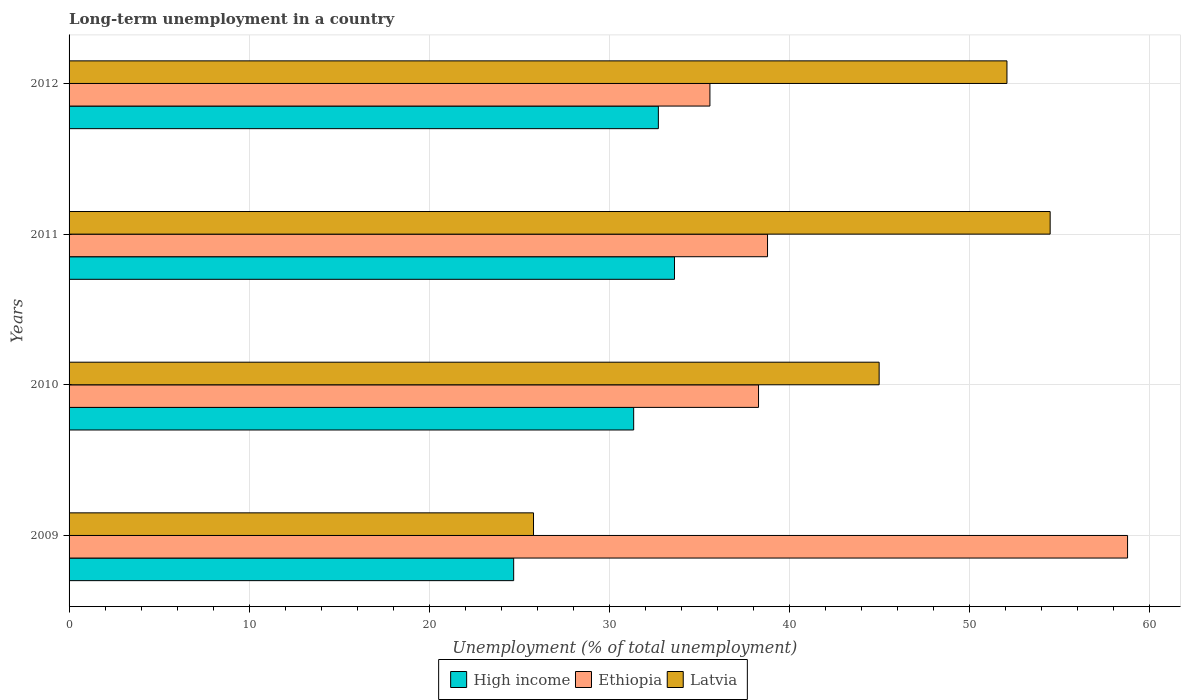Are the number of bars per tick equal to the number of legend labels?
Offer a very short reply. Yes. Are the number of bars on each tick of the Y-axis equal?
Offer a very short reply. Yes. How many bars are there on the 2nd tick from the top?
Provide a succinct answer. 3. How many bars are there on the 1st tick from the bottom?
Provide a short and direct response. 3. In how many cases, is the number of bars for a given year not equal to the number of legend labels?
Make the answer very short. 0. What is the percentage of long-term unemployed population in Ethiopia in 2009?
Your answer should be compact. 58.8. Across all years, what is the maximum percentage of long-term unemployed population in Latvia?
Your response must be concise. 54.5. Across all years, what is the minimum percentage of long-term unemployed population in Latvia?
Provide a short and direct response. 25.8. In which year was the percentage of long-term unemployed population in Latvia minimum?
Offer a very short reply. 2009. What is the total percentage of long-term unemployed population in Latvia in the graph?
Make the answer very short. 177.4. What is the difference between the percentage of long-term unemployed population in Ethiopia in 2010 and that in 2012?
Your answer should be very brief. 2.7. What is the difference between the percentage of long-term unemployed population in Latvia in 2011 and the percentage of long-term unemployed population in Ethiopia in 2012?
Keep it short and to the point. 18.9. What is the average percentage of long-term unemployed population in High income per year?
Provide a short and direct response. 30.61. In the year 2010, what is the difference between the percentage of long-term unemployed population in High income and percentage of long-term unemployed population in Ethiopia?
Make the answer very short. -6.94. What is the ratio of the percentage of long-term unemployed population in Ethiopia in 2009 to that in 2011?
Keep it short and to the point. 1.52. Is the difference between the percentage of long-term unemployed population in High income in 2009 and 2011 greater than the difference between the percentage of long-term unemployed population in Ethiopia in 2009 and 2011?
Ensure brevity in your answer.  No. What is the difference between the highest and the second highest percentage of long-term unemployed population in High income?
Offer a very short reply. 0.9. What is the difference between the highest and the lowest percentage of long-term unemployed population in Ethiopia?
Keep it short and to the point. 23.2. In how many years, is the percentage of long-term unemployed population in Latvia greater than the average percentage of long-term unemployed population in Latvia taken over all years?
Your answer should be compact. 3. What does the 2nd bar from the top in 2012 represents?
Provide a succinct answer. Ethiopia. What does the 1st bar from the bottom in 2012 represents?
Offer a terse response. High income. How many bars are there?
Provide a succinct answer. 12. How many years are there in the graph?
Provide a short and direct response. 4. What is the difference between two consecutive major ticks on the X-axis?
Make the answer very short. 10. Does the graph contain any zero values?
Keep it short and to the point. No. Does the graph contain grids?
Your response must be concise. Yes. How are the legend labels stacked?
Offer a terse response. Horizontal. What is the title of the graph?
Give a very brief answer. Long-term unemployment in a country. Does "Greenland" appear as one of the legend labels in the graph?
Ensure brevity in your answer.  No. What is the label or title of the X-axis?
Make the answer very short. Unemployment (% of total unemployment). What is the label or title of the Y-axis?
Ensure brevity in your answer.  Years. What is the Unemployment (% of total unemployment) in High income in 2009?
Make the answer very short. 24.7. What is the Unemployment (% of total unemployment) of Ethiopia in 2009?
Keep it short and to the point. 58.8. What is the Unemployment (% of total unemployment) in Latvia in 2009?
Your response must be concise. 25.8. What is the Unemployment (% of total unemployment) in High income in 2010?
Keep it short and to the point. 31.36. What is the Unemployment (% of total unemployment) in Ethiopia in 2010?
Your response must be concise. 38.3. What is the Unemployment (% of total unemployment) of Latvia in 2010?
Offer a very short reply. 45. What is the Unemployment (% of total unemployment) of High income in 2011?
Provide a succinct answer. 33.63. What is the Unemployment (% of total unemployment) in Ethiopia in 2011?
Give a very brief answer. 38.8. What is the Unemployment (% of total unemployment) of Latvia in 2011?
Ensure brevity in your answer.  54.5. What is the Unemployment (% of total unemployment) of High income in 2012?
Keep it short and to the point. 32.74. What is the Unemployment (% of total unemployment) in Ethiopia in 2012?
Your response must be concise. 35.6. What is the Unemployment (% of total unemployment) in Latvia in 2012?
Your answer should be very brief. 52.1. Across all years, what is the maximum Unemployment (% of total unemployment) in High income?
Make the answer very short. 33.63. Across all years, what is the maximum Unemployment (% of total unemployment) in Ethiopia?
Provide a succinct answer. 58.8. Across all years, what is the maximum Unemployment (% of total unemployment) of Latvia?
Make the answer very short. 54.5. Across all years, what is the minimum Unemployment (% of total unemployment) in High income?
Provide a succinct answer. 24.7. Across all years, what is the minimum Unemployment (% of total unemployment) of Ethiopia?
Ensure brevity in your answer.  35.6. Across all years, what is the minimum Unemployment (% of total unemployment) of Latvia?
Your answer should be compact. 25.8. What is the total Unemployment (% of total unemployment) of High income in the graph?
Keep it short and to the point. 122.43. What is the total Unemployment (% of total unemployment) of Ethiopia in the graph?
Ensure brevity in your answer.  171.5. What is the total Unemployment (% of total unemployment) in Latvia in the graph?
Offer a terse response. 177.4. What is the difference between the Unemployment (% of total unemployment) of High income in 2009 and that in 2010?
Ensure brevity in your answer.  -6.67. What is the difference between the Unemployment (% of total unemployment) of Latvia in 2009 and that in 2010?
Your response must be concise. -19.2. What is the difference between the Unemployment (% of total unemployment) of High income in 2009 and that in 2011?
Your answer should be very brief. -8.93. What is the difference between the Unemployment (% of total unemployment) of Ethiopia in 2009 and that in 2011?
Keep it short and to the point. 20. What is the difference between the Unemployment (% of total unemployment) of Latvia in 2009 and that in 2011?
Provide a short and direct response. -28.7. What is the difference between the Unemployment (% of total unemployment) of High income in 2009 and that in 2012?
Your response must be concise. -8.04. What is the difference between the Unemployment (% of total unemployment) in Ethiopia in 2009 and that in 2012?
Offer a terse response. 23.2. What is the difference between the Unemployment (% of total unemployment) of Latvia in 2009 and that in 2012?
Your answer should be very brief. -26.3. What is the difference between the Unemployment (% of total unemployment) in High income in 2010 and that in 2011?
Your answer should be very brief. -2.27. What is the difference between the Unemployment (% of total unemployment) of Ethiopia in 2010 and that in 2011?
Give a very brief answer. -0.5. What is the difference between the Unemployment (% of total unemployment) in Latvia in 2010 and that in 2011?
Your answer should be very brief. -9.5. What is the difference between the Unemployment (% of total unemployment) of High income in 2010 and that in 2012?
Your response must be concise. -1.37. What is the difference between the Unemployment (% of total unemployment) in Latvia in 2010 and that in 2012?
Keep it short and to the point. -7.1. What is the difference between the Unemployment (% of total unemployment) of High income in 2011 and that in 2012?
Provide a succinct answer. 0.9. What is the difference between the Unemployment (% of total unemployment) of Latvia in 2011 and that in 2012?
Keep it short and to the point. 2.4. What is the difference between the Unemployment (% of total unemployment) of High income in 2009 and the Unemployment (% of total unemployment) of Ethiopia in 2010?
Make the answer very short. -13.6. What is the difference between the Unemployment (% of total unemployment) of High income in 2009 and the Unemployment (% of total unemployment) of Latvia in 2010?
Your answer should be very brief. -20.3. What is the difference between the Unemployment (% of total unemployment) in High income in 2009 and the Unemployment (% of total unemployment) in Ethiopia in 2011?
Give a very brief answer. -14.1. What is the difference between the Unemployment (% of total unemployment) in High income in 2009 and the Unemployment (% of total unemployment) in Latvia in 2011?
Keep it short and to the point. -29.8. What is the difference between the Unemployment (% of total unemployment) in High income in 2009 and the Unemployment (% of total unemployment) in Ethiopia in 2012?
Your response must be concise. -10.9. What is the difference between the Unemployment (% of total unemployment) in High income in 2009 and the Unemployment (% of total unemployment) in Latvia in 2012?
Offer a very short reply. -27.4. What is the difference between the Unemployment (% of total unemployment) of Ethiopia in 2009 and the Unemployment (% of total unemployment) of Latvia in 2012?
Offer a very short reply. 6.7. What is the difference between the Unemployment (% of total unemployment) of High income in 2010 and the Unemployment (% of total unemployment) of Ethiopia in 2011?
Ensure brevity in your answer.  -7.44. What is the difference between the Unemployment (% of total unemployment) of High income in 2010 and the Unemployment (% of total unemployment) of Latvia in 2011?
Ensure brevity in your answer.  -23.14. What is the difference between the Unemployment (% of total unemployment) in Ethiopia in 2010 and the Unemployment (% of total unemployment) in Latvia in 2011?
Your answer should be compact. -16.2. What is the difference between the Unemployment (% of total unemployment) of High income in 2010 and the Unemployment (% of total unemployment) of Ethiopia in 2012?
Give a very brief answer. -4.24. What is the difference between the Unemployment (% of total unemployment) in High income in 2010 and the Unemployment (% of total unemployment) in Latvia in 2012?
Provide a succinct answer. -20.74. What is the difference between the Unemployment (% of total unemployment) in High income in 2011 and the Unemployment (% of total unemployment) in Ethiopia in 2012?
Provide a short and direct response. -1.97. What is the difference between the Unemployment (% of total unemployment) in High income in 2011 and the Unemployment (% of total unemployment) in Latvia in 2012?
Make the answer very short. -18.47. What is the average Unemployment (% of total unemployment) in High income per year?
Your answer should be very brief. 30.61. What is the average Unemployment (% of total unemployment) in Ethiopia per year?
Provide a succinct answer. 42.88. What is the average Unemployment (% of total unemployment) of Latvia per year?
Your answer should be compact. 44.35. In the year 2009, what is the difference between the Unemployment (% of total unemployment) of High income and Unemployment (% of total unemployment) of Ethiopia?
Keep it short and to the point. -34.1. In the year 2009, what is the difference between the Unemployment (% of total unemployment) in High income and Unemployment (% of total unemployment) in Latvia?
Offer a very short reply. -1.1. In the year 2009, what is the difference between the Unemployment (% of total unemployment) in Ethiopia and Unemployment (% of total unemployment) in Latvia?
Keep it short and to the point. 33. In the year 2010, what is the difference between the Unemployment (% of total unemployment) of High income and Unemployment (% of total unemployment) of Ethiopia?
Ensure brevity in your answer.  -6.94. In the year 2010, what is the difference between the Unemployment (% of total unemployment) in High income and Unemployment (% of total unemployment) in Latvia?
Provide a succinct answer. -13.64. In the year 2011, what is the difference between the Unemployment (% of total unemployment) of High income and Unemployment (% of total unemployment) of Ethiopia?
Your answer should be compact. -5.17. In the year 2011, what is the difference between the Unemployment (% of total unemployment) in High income and Unemployment (% of total unemployment) in Latvia?
Your answer should be very brief. -20.87. In the year 2011, what is the difference between the Unemployment (% of total unemployment) of Ethiopia and Unemployment (% of total unemployment) of Latvia?
Make the answer very short. -15.7. In the year 2012, what is the difference between the Unemployment (% of total unemployment) in High income and Unemployment (% of total unemployment) in Ethiopia?
Your response must be concise. -2.86. In the year 2012, what is the difference between the Unemployment (% of total unemployment) of High income and Unemployment (% of total unemployment) of Latvia?
Your response must be concise. -19.36. In the year 2012, what is the difference between the Unemployment (% of total unemployment) in Ethiopia and Unemployment (% of total unemployment) in Latvia?
Provide a short and direct response. -16.5. What is the ratio of the Unemployment (% of total unemployment) of High income in 2009 to that in 2010?
Offer a terse response. 0.79. What is the ratio of the Unemployment (% of total unemployment) of Ethiopia in 2009 to that in 2010?
Give a very brief answer. 1.54. What is the ratio of the Unemployment (% of total unemployment) of Latvia in 2009 to that in 2010?
Your answer should be very brief. 0.57. What is the ratio of the Unemployment (% of total unemployment) of High income in 2009 to that in 2011?
Provide a short and direct response. 0.73. What is the ratio of the Unemployment (% of total unemployment) of Ethiopia in 2009 to that in 2011?
Give a very brief answer. 1.52. What is the ratio of the Unemployment (% of total unemployment) of Latvia in 2009 to that in 2011?
Your response must be concise. 0.47. What is the ratio of the Unemployment (% of total unemployment) in High income in 2009 to that in 2012?
Your answer should be very brief. 0.75. What is the ratio of the Unemployment (% of total unemployment) in Ethiopia in 2009 to that in 2012?
Your answer should be compact. 1.65. What is the ratio of the Unemployment (% of total unemployment) in Latvia in 2009 to that in 2012?
Offer a very short reply. 0.5. What is the ratio of the Unemployment (% of total unemployment) of High income in 2010 to that in 2011?
Provide a short and direct response. 0.93. What is the ratio of the Unemployment (% of total unemployment) in Ethiopia in 2010 to that in 2011?
Your answer should be very brief. 0.99. What is the ratio of the Unemployment (% of total unemployment) of Latvia in 2010 to that in 2011?
Your response must be concise. 0.83. What is the ratio of the Unemployment (% of total unemployment) in High income in 2010 to that in 2012?
Keep it short and to the point. 0.96. What is the ratio of the Unemployment (% of total unemployment) of Ethiopia in 2010 to that in 2012?
Your response must be concise. 1.08. What is the ratio of the Unemployment (% of total unemployment) of Latvia in 2010 to that in 2012?
Keep it short and to the point. 0.86. What is the ratio of the Unemployment (% of total unemployment) of High income in 2011 to that in 2012?
Ensure brevity in your answer.  1.03. What is the ratio of the Unemployment (% of total unemployment) in Ethiopia in 2011 to that in 2012?
Your answer should be compact. 1.09. What is the ratio of the Unemployment (% of total unemployment) in Latvia in 2011 to that in 2012?
Ensure brevity in your answer.  1.05. What is the difference between the highest and the second highest Unemployment (% of total unemployment) of High income?
Your answer should be compact. 0.9. What is the difference between the highest and the second highest Unemployment (% of total unemployment) in Ethiopia?
Your response must be concise. 20. What is the difference between the highest and the second highest Unemployment (% of total unemployment) of Latvia?
Offer a very short reply. 2.4. What is the difference between the highest and the lowest Unemployment (% of total unemployment) of High income?
Your answer should be very brief. 8.93. What is the difference between the highest and the lowest Unemployment (% of total unemployment) in Ethiopia?
Provide a succinct answer. 23.2. What is the difference between the highest and the lowest Unemployment (% of total unemployment) in Latvia?
Keep it short and to the point. 28.7. 